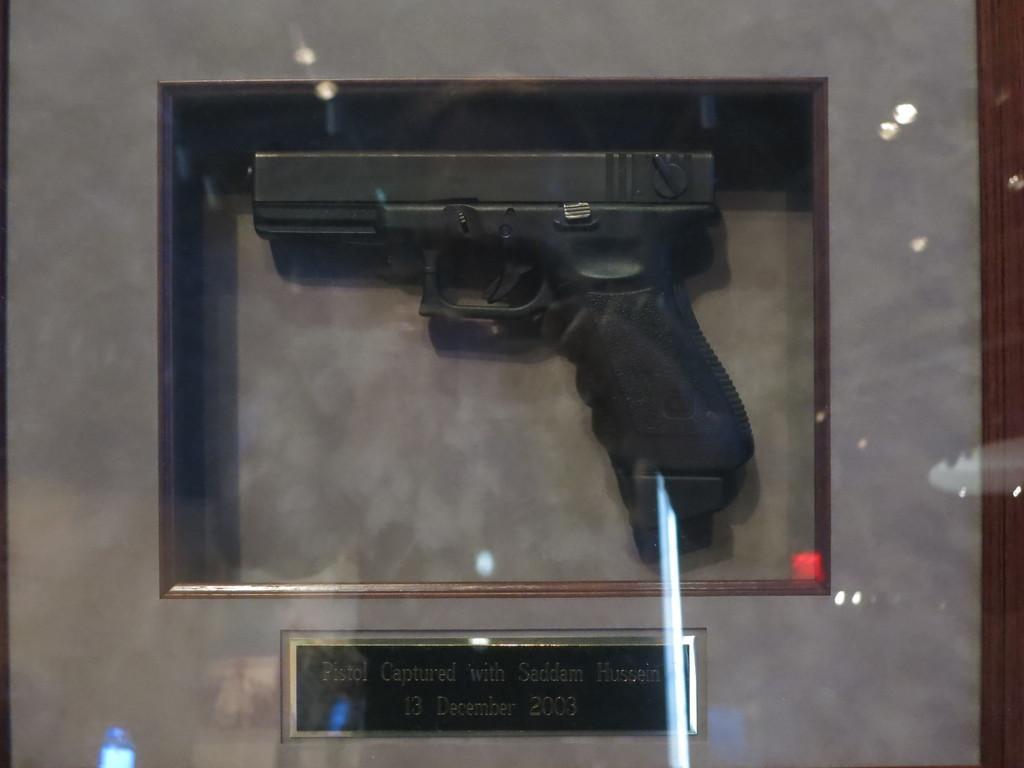Please provide a concise description of this image. This picture shows a gun in the glass box and we see a board with some text on it. 